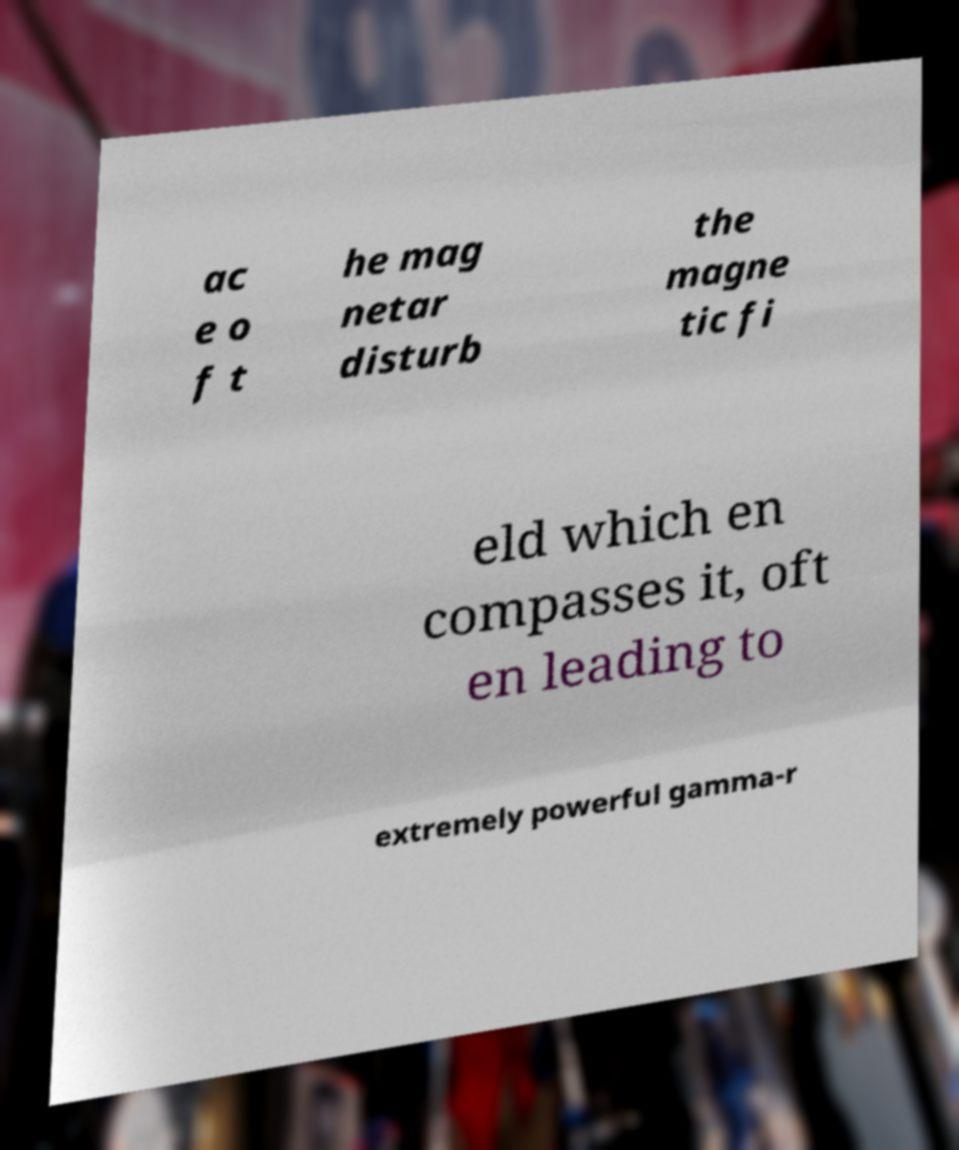There's text embedded in this image that I need extracted. Can you transcribe it verbatim? ac e o f t he mag netar disturb the magne tic fi eld which en compasses it, oft en leading to extremely powerful gamma-r 